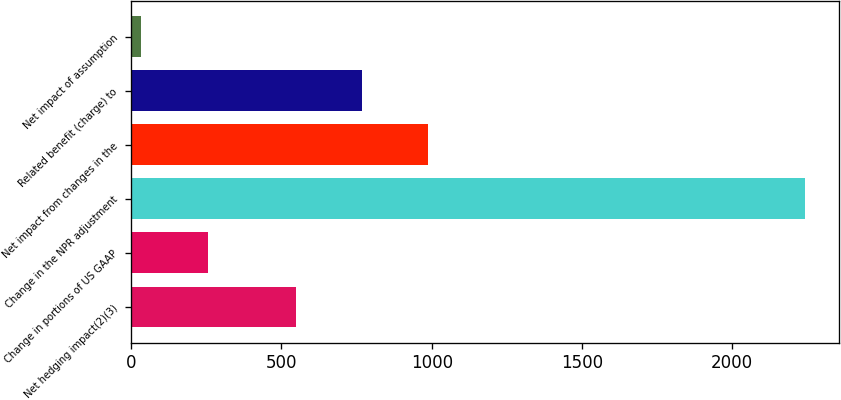<chart> <loc_0><loc_0><loc_500><loc_500><bar_chart><fcel>Net hedging impact(2)(3)<fcel>Change in portions of US GAAP<fcel>Change in the NPR adjustment<fcel>Net impact from changes in the<fcel>Related benefit (charge) to<fcel>Net impact of assumption<nl><fcel>547<fcel>254.9<fcel>2243<fcel>988.8<fcel>767.9<fcel>34<nl></chart> 